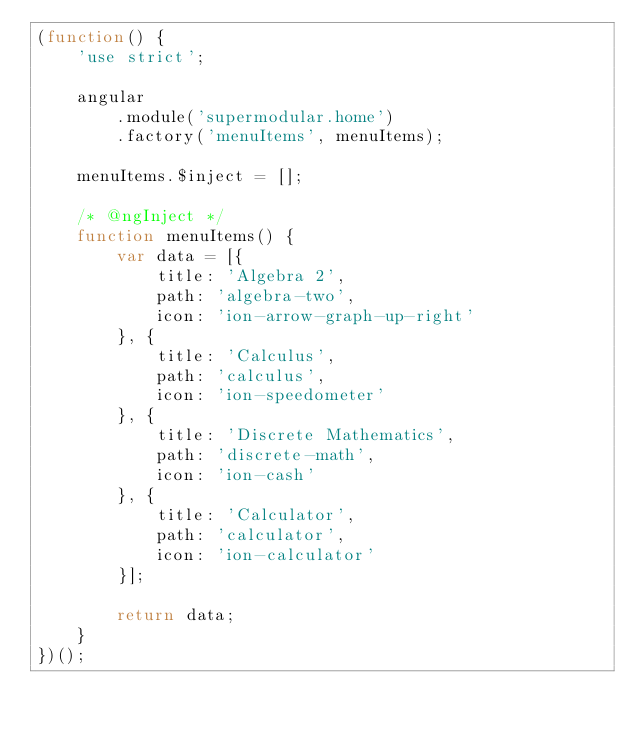<code> <loc_0><loc_0><loc_500><loc_500><_JavaScript_>(function() {
	'use strict';

	angular
		.module('supermodular.home')
		.factory('menuItems', menuItems);

	menuItems.$inject = [];

	/* @ngInject */
	function menuItems() {
		var data = [{
			title: 'Algebra 2',
			path: 'algebra-two',
			icon: 'ion-arrow-graph-up-right'
		}, {
			title: 'Calculus',
			path: 'calculus',
			icon: 'ion-speedometer'
		}, {
			title: 'Discrete Mathematics',
			path: 'discrete-math',
			icon: 'ion-cash'
		}, {
			title: 'Calculator',
			path: 'calculator',
			icon: 'ion-calculator'
		}];

		return data;
	}
})();
</code> 